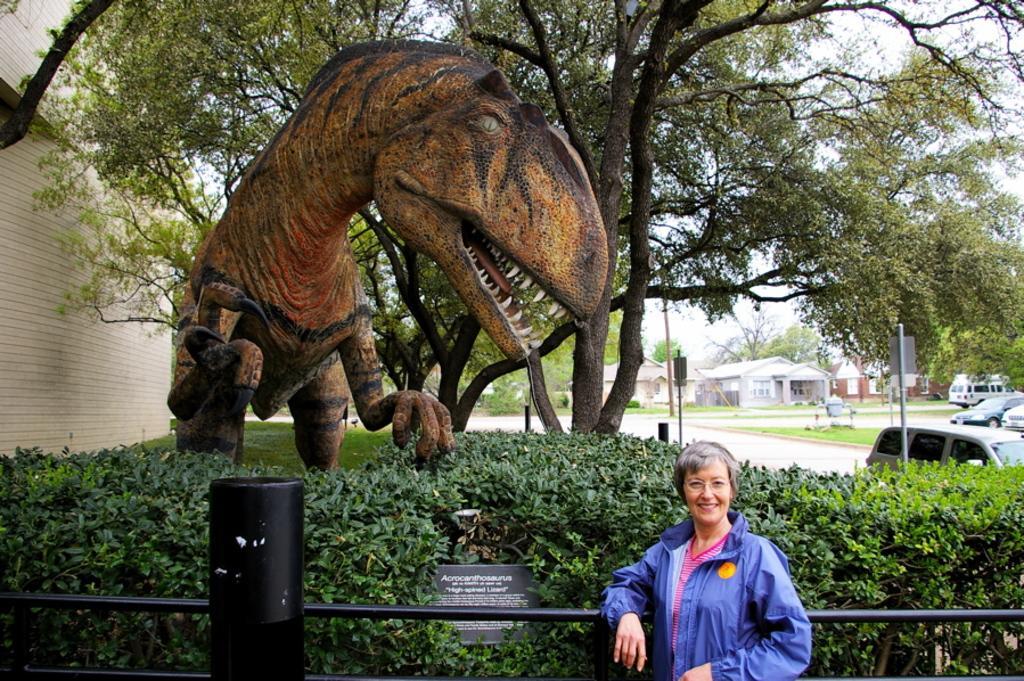Could you give a brief overview of what you see in this image? In this image we can see one dinosaur statue with a name board, one woman standing near the fence, one big wall, some houses, some vehicles and some objects are on the surface. There are some trees, plants, bushes and some green grass. Some poles, some boards, one road and at the top there is the sky. 